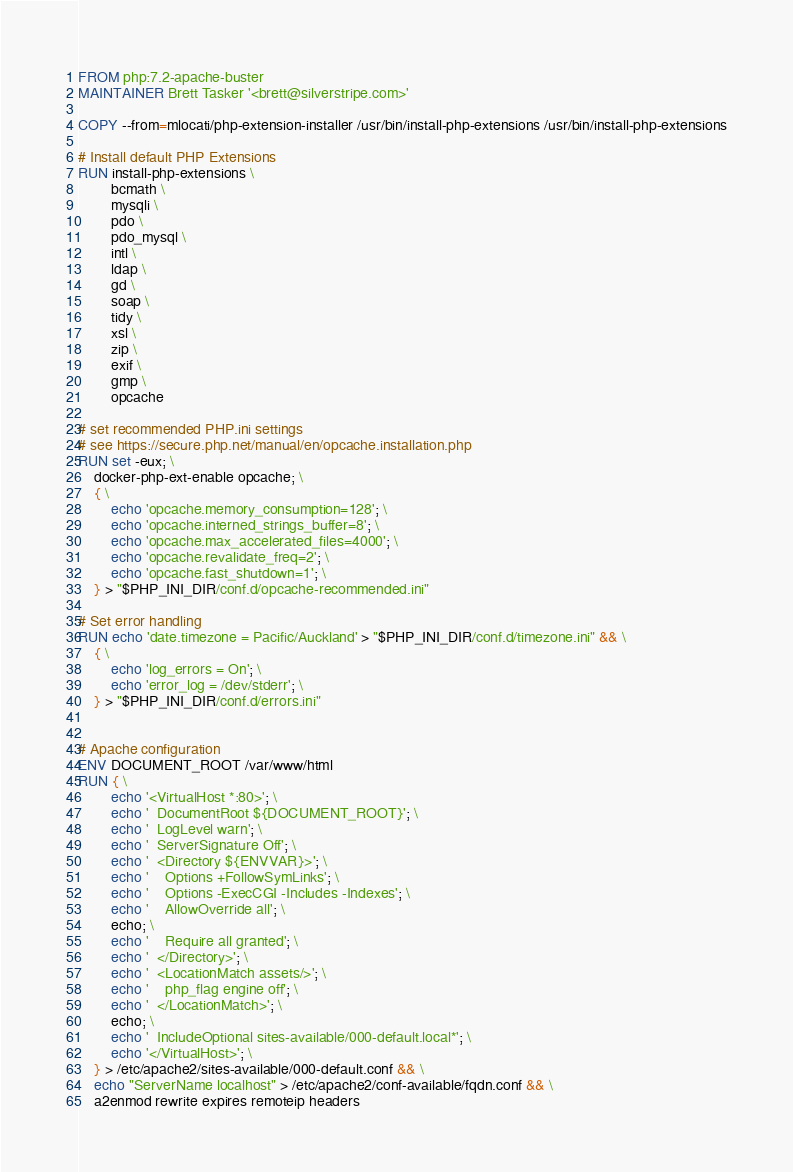<code> <loc_0><loc_0><loc_500><loc_500><_Dockerfile_>FROM php:7.2-apache-buster
MAINTAINER Brett Tasker '<brett@silverstripe.com>'

COPY --from=mlocati/php-extension-installer /usr/bin/install-php-extensions /usr/bin/install-php-extensions

# Install default PHP Extensions
RUN install-php-extensions \
        bcmath \
        mysqli \
        pdo \
        pdo_mysql \
        intl \
        ldap \
        gd \
        soap \
        tidy \
        xsl \
        zip \
        exif \
        gmp \
        opcache

# set recommended PHP.ini settings
# see https://secure.php.net/manual/en/opcache.installation.php
RUN set -eux; \
	docker-php-ext-enable opcache; \
	{ \
		echo 'opcache.memory_consumption=128'; \
		echo 'opcache.interned_strings_buffer=8'; \
		echo 'opcache.max_accelerated_files=4000'; \
		echo 'opcache.revalidate_freq=2'; \
		echo 'opcache.fast_shutdown=1'; \
	} > "$PHP_INI_DIR/conf.d/opcache-recommended.ini"

# Set error handling
RUN echo 'date.timezone = Pacific/Auckland' > "$PHP_INI_DIR/conf.d/timezone.ini" && \ 
    { \
        echo 'log_errors = On'; \
        echo 'error_log = /dev/stderr'; \
    } > "$PHP_INI_DIR/conf.d/errors.ini"


# Apache configuration
ENV DOCUMENT_ROOT /var/www/html
RUN { \
        echo '<VirtualHost *:80>'; \
        echo '  DocumentRoot ${DOCUMENT_ROOT}'; \
        echo '  LogLevel warn'; \
        echo '  ServerSignature Off'; \
        echo '  <Directory ${ENVVAR}>'; \
        echo '    Options +FollowSymLinks'; \
        echo '    Options -ExecCGI -Includes -Indexes'; \
        echo '    AllowOverride all'; \
        echo; \
        echo '    Require all granted'; \
        echo '  </Directory>'; \
        echo '  <LocationMatch assets/>'; \
        echo '    php_flag engine off'; \
        echo '  </LocationMatch>'; \
        echo; \
        echo '  IncludeOptional sites-available/000-default.local*'; \
        echo '</VirtualHost>'; \
	} > /etc/apache2/sites-available/000-default.conf && \
    echo "ServerName localhost" > /etc/apache2/conf-available/fqdn.conf && \
    a2enmod rewrite expires remoteip headers
</code> 